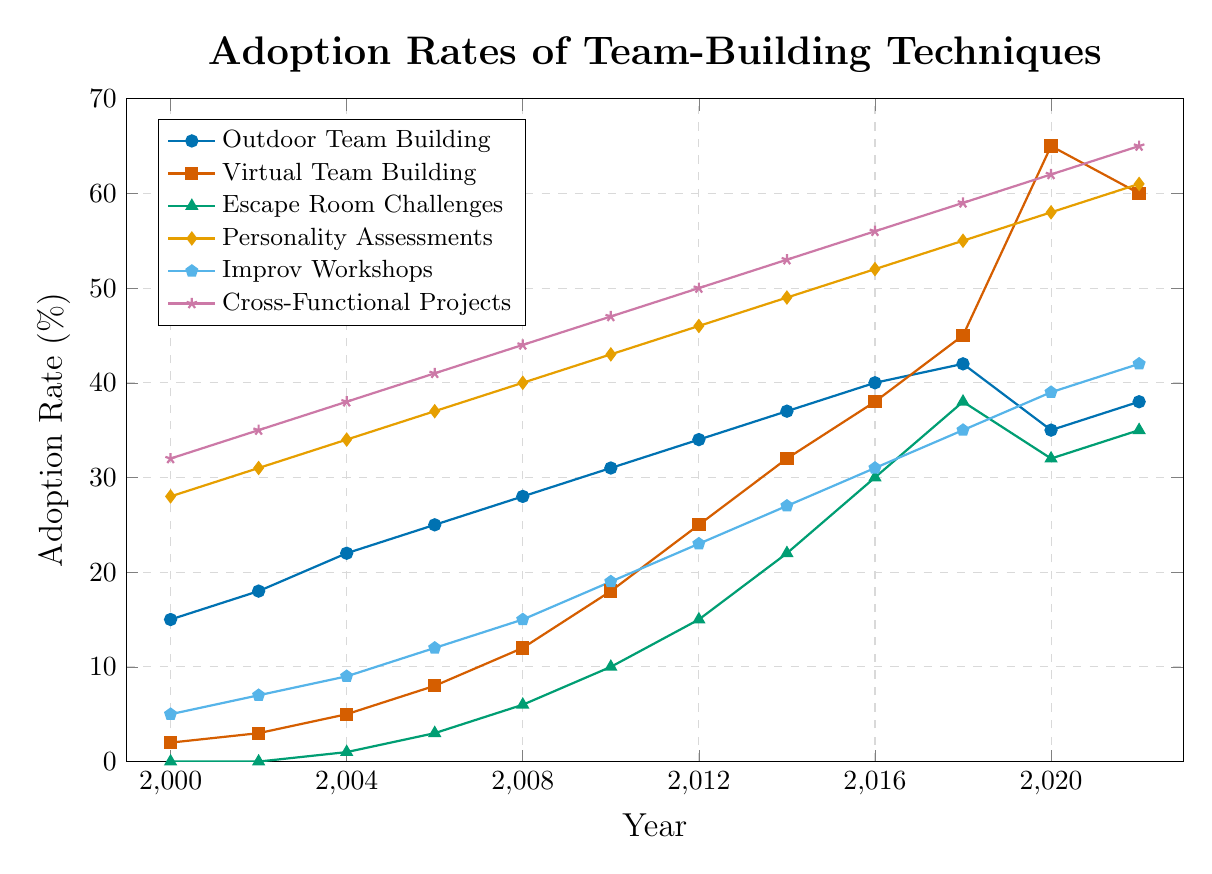What year saw the highest adoption rate for Virtual Team Building? Look at the line for Virtual Team Building (in red). The peak of the line is at the year 2020 with the highest adoption rate.
Answer: 2020 Between 2000 and 2022, which team-building technique had the most consistent growth rate? Examine all lines. Cross-Functional Projects (in purple) shows a steady, consistent increase from 2000 to 2022 without any noticeable decline.
Answer: Cross-Functional Projects What's the sum of adoption rates for Escape Room Challenges and Improv Workshops in 2012? Find the 2012 data points for both techniques: Escape Room Challenges (15) and Improv Workshops (23). Add them together (15 + 23).
Answer: 38 How did Outdoor Team Building's adoption rate change between 2018 and 2020? Look at the data points for Outdoor Team Building for 2018 (42) and 2020 (35). The change is 35 - 42, which is a decline.
Answer: Decreased Which technique surpassed a 50% adoption rate by 2016? Locate the 2016 points for each line. Only Cross-Functional Projects (in purple) and Personality Assessments (in yellow) exceeded 50% by 2016.
Answer: Cross-Functional Projects, Personality Assessments Compare the adoption rates of Virtual Team Building and Personality Assessments in 2022. Which was higher? Find the 2022 points for both lines: Virtual Team Building (60) and Personality Assessments (61). Personality Assessments is slightly higher.
Answer: Personality Assessments How many techniques reached an adoption rate above 30% by 2010? Examine the 2010 data points for each technique. Outdoor Team Building (31), Personality Assessments (43), and Cross-Functional Projects (47) exceeded 30%.
Answer: 3 What is the average adoption rate of Cross-Functional Projects from 2000 to 2022? Sum the yearly data for Cross-Functional Projects (32+35+38+41+44+47+50+53+56+59+62+65) = 582. Divide by the number of years (12).
Answer: 48.5 Which technique had the largest increase in adoption rate between 2010 and 2012? Calculate the differences: Outdoor Team Building (34-31=3), Virtual Team Building (25-18=7), Escape Room Challenges (15-10=5), Personality Assessments (46-43=3), Improv Workshops (23-19=4), Cross-Functional Projects (50-47=3). Virtual Team Building has the largest increase.
Answer: Virtual Team Building By how much did the adoption rate of Personality Assessments increase from 2000 to 2022? Find the adoption rates for Personality Assessments for 2000 (28) and 2022 (61). The increase is 61 - 28.
Answer: 33 